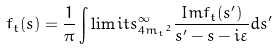Convert formula to latex. <formula><loc_0><loc_0><loc_500><loc_500>f _ { t } ( s ) = \frac { 1 } { \pi } \int \lim i t s _ { 4 { m _ { t } } ^ { 2 } } ^ { \infty } \frac { I m f _ { t } ( s ^ { \prime } ) } { s ^ { \prime } - s - i \varepsilon } d s ^ { \prime }</formula> 